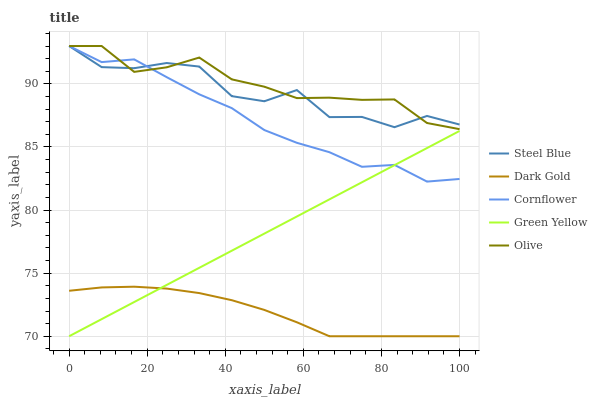Does Dark Gold have the minimum area under the curve?
Answer yes or no. Yes. Does Olive have the maximum area under the curve?
Answer yes or no. Yes. Does Cornflower have the minimum area under the curve?
Answer yes or no. No. Does Cornflower have the maximum area under the curve?
Answer yes or no. No. Is Green Yellow the smoothest?
Answer yes or no. Yes. Is Steel Blue the roughest?
Answer yes or no. Yes. Is Cornflower the smoothest?
Answer yes or no. No. Is Cornflower the roughest?
Answer yes or no. No. Does Green Yellow have the lowest value?
Answer yes or no. Yes. Does Cornflower have the lowest value?
Answer yes or no. No. Does Steel Blue have the highest value?
Answer yes or no. Yes. Does Green Yellow have the highest value?
Answer yes or no. No. Is Dark Gold less than Steel Blue?
Answer yes or no. Yes. Is Cornflower greater than Dark Gold?
Answer yes or no. Yes. Does Green Yellow intersect Dark Gold?
Answer yes or no. Yes. Is Green Yellow less than Dark Gold?
Answer yes or no. No. Is Green Yellow greater than Dark Gold?
Answer yes or no. No. Does Dark Gold intersect Steel Blue?
Answer yes or no. No. 